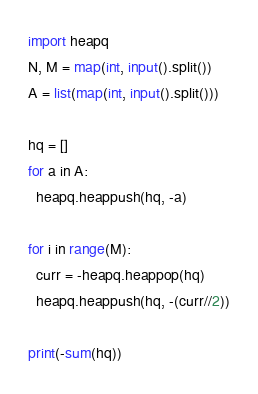<code> <loc_0><loc_0><loc_500><loc_500><_Python_>import heapq
N, M = map(int, input().split())
A = list(map(int, input().split()))

hq = []
for a in A:
  heapq.heappush(hq, -a)
  
for i in range(M):
  curr = -heapq.heappop(hq)
  heapq.heappush(hq, -(curr//2))
  
print(-sum(hq))</code> 